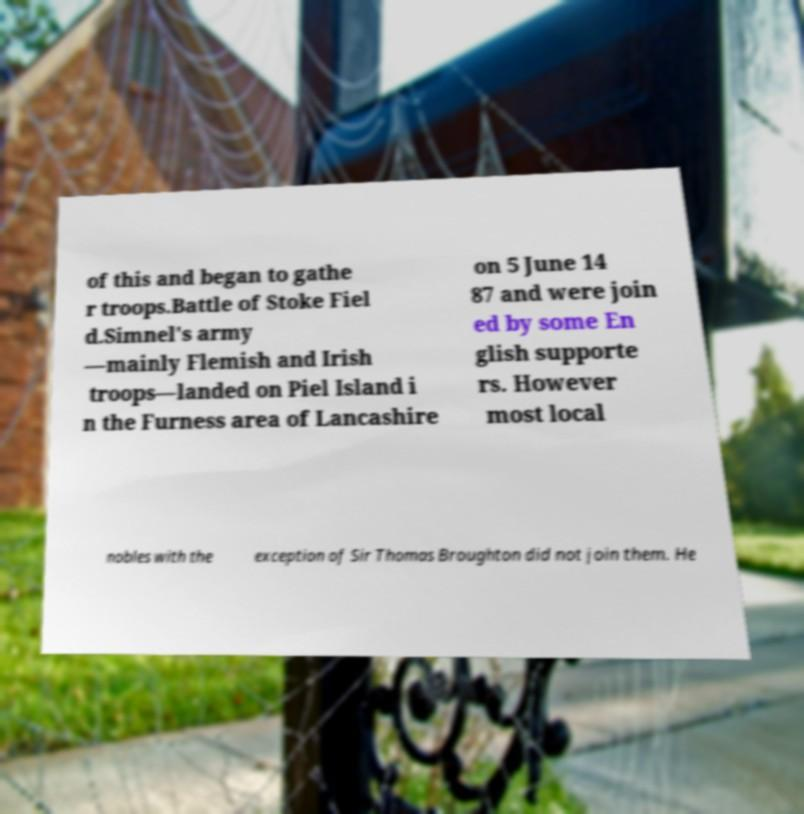There's text embedded in this image that I need extracted. Can you transcribe it verbatim? of this and began to gathe r troops.Battle of Stoke Fiel d.Simnel's army —mainly Flemish and Irish troops—landed on Piel Island i n the Furness area of Lancashire on 5 June 14 87 and were join ed by some En glish supporte rs. However most local nobles with the exception of Sir Thomas Broughton did not join them. He 